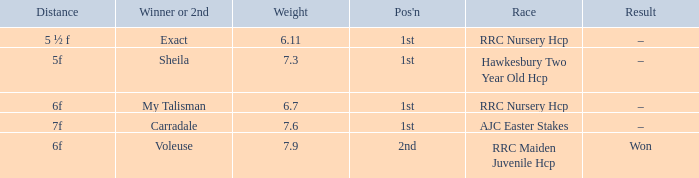What is the weight number when the distance was 5 ½ f? 1.0. 